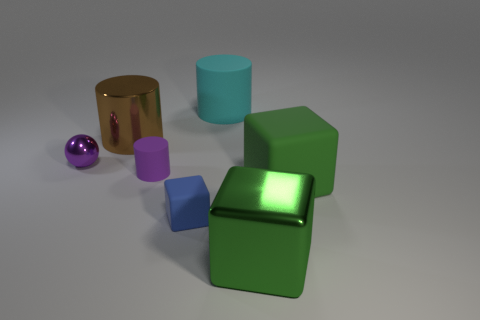What shape is the blue rubber object?
Your answer should be compact. Cube. What shape is the green matte thing that is the same size as the brown object?
Offer a terse response. Cube. Is there anything else that is the same color as the tiny metal object?
Provide a succinct answer. Yes. There is a green object that is made of the same material as the big cyan cylinder; what size is it?
Make the answer very short. Large. Is the shape of the brown object the same as the metallic thing in front of the big green rubber thing?
Offer a very short reply. No. How big is the green matte cube?
Make the answer very short. Large. Are there fewer brown metal cylinders that are in front of the large metal cube than green rubber cubes?
Provide a short and direct response. Yes. What number of green matte objects are the same size as the purple shiny sphere?
Ensure brevity in your answer.  0. What is the shape of the tiny rubber object that is the same color as the small ball?
Make the answer very short. Cylinder. There is a metal object that is on the right side of the brown object; is its color the same as the rubber object that is on the right side of the metal block?
Offer a very short reply. Yes. 